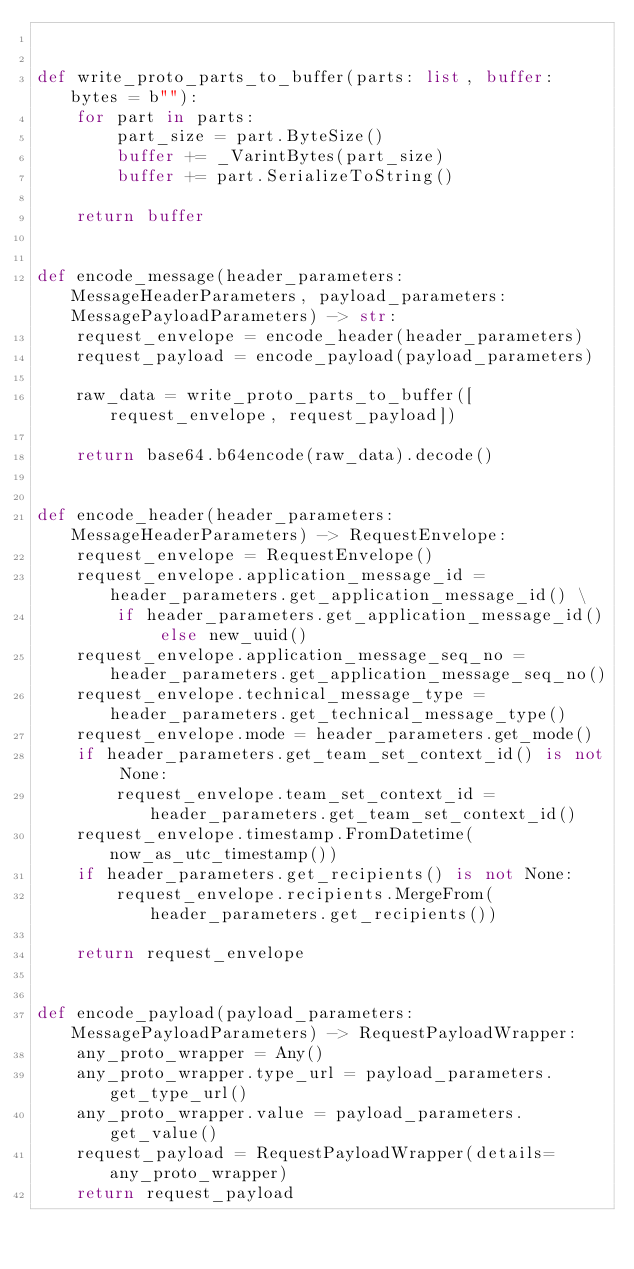Convert code to text. <code><loc_0><loc_0><loc_500><loc_500><_Python_>

def write_proto_parts_to_buffer(parts: list, buffer: bytes = b""):
    for part in parts:
        part_size = part.ByteSize()
        buffer += _VarintBytes(part_size)
        buffer += part.SerializeToString()

    return buffer


def encode_message(header_parameters: MessageHeaderParameters, payload_parameters: MessagePayloadParameters) -> str:
    request_envelope = encode_header(header_parameters)
    request_payload = encode_payload(payload_parameters)

    raw_data = write_proto_parts_to_buffer([request_envelope, request_payload])

    return base64.b64encode(raw_data).decode()


def encode_header(header_parameters: MessageHeaderParameters) -> RequestEnvelope:
    request_envelope = RequestEnvelope()
    request_envelope.application_message_id = header_parameters.get_application_message_id() \
        if header_parameters.get_application_message_id() else new_uuid()
    request_envelope.application_message_seq_no = header_parameters.get_application_message_seq_no()
    request_envelope.technical_message_type = header_parameters.get_technical_message_type()
    request_envelope.mode = header_parameters.get_mode()
    if header_parameters.get_team_set_context_id() is not None:
        request_envelope.team_set_context_id = header_parameters.get_team_set_context_id()
    request_envelope.timestamp.FromDatetime(now_as_utc_timestamp())
    if header_parameters.get_recipients() is not None:
        request_envelope.recipients.MergeFrom(header_parameters.get_recipients())

    return request_envelope


def encode_payload(payload_parameters: MessagePayloadParameters) -> RequestPayloadWrapper:
    any_proto_wrapper = Any()
    any_proto_wrapper.type_url = payload_parameters.get_type_url()
    any_proto_wrapper.value = payload_parameters.get_value()
    request_payload = RequestPayloadWrapper(details=any_proto_wrapper)
    return request_payload
</code> 